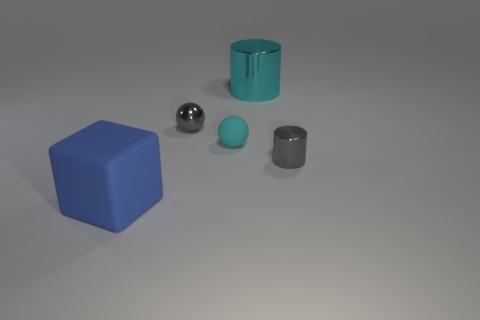Add 1 small gray metallic cylinders. How many objects exist? 6 Subtract 1 balls. How many balls are left? 1 Subtract all cylinders. How many objects are left? 3 Subtract all blue rubber objects. Subtract all small metal cylinders. How many objects are left? 3 Add 2 big blue things. How many big blue things are left? 3 Add 5 cyan cylinders. How many cyan cylinders exist? 6 Subtract 0 blue cylinders. How many objects are left? 5 Subtract all cyan spheres. Subtract all blue cubes. How many spheres are left? 1 Subtract all blue balls. How many cyan cylinders are left? 1 